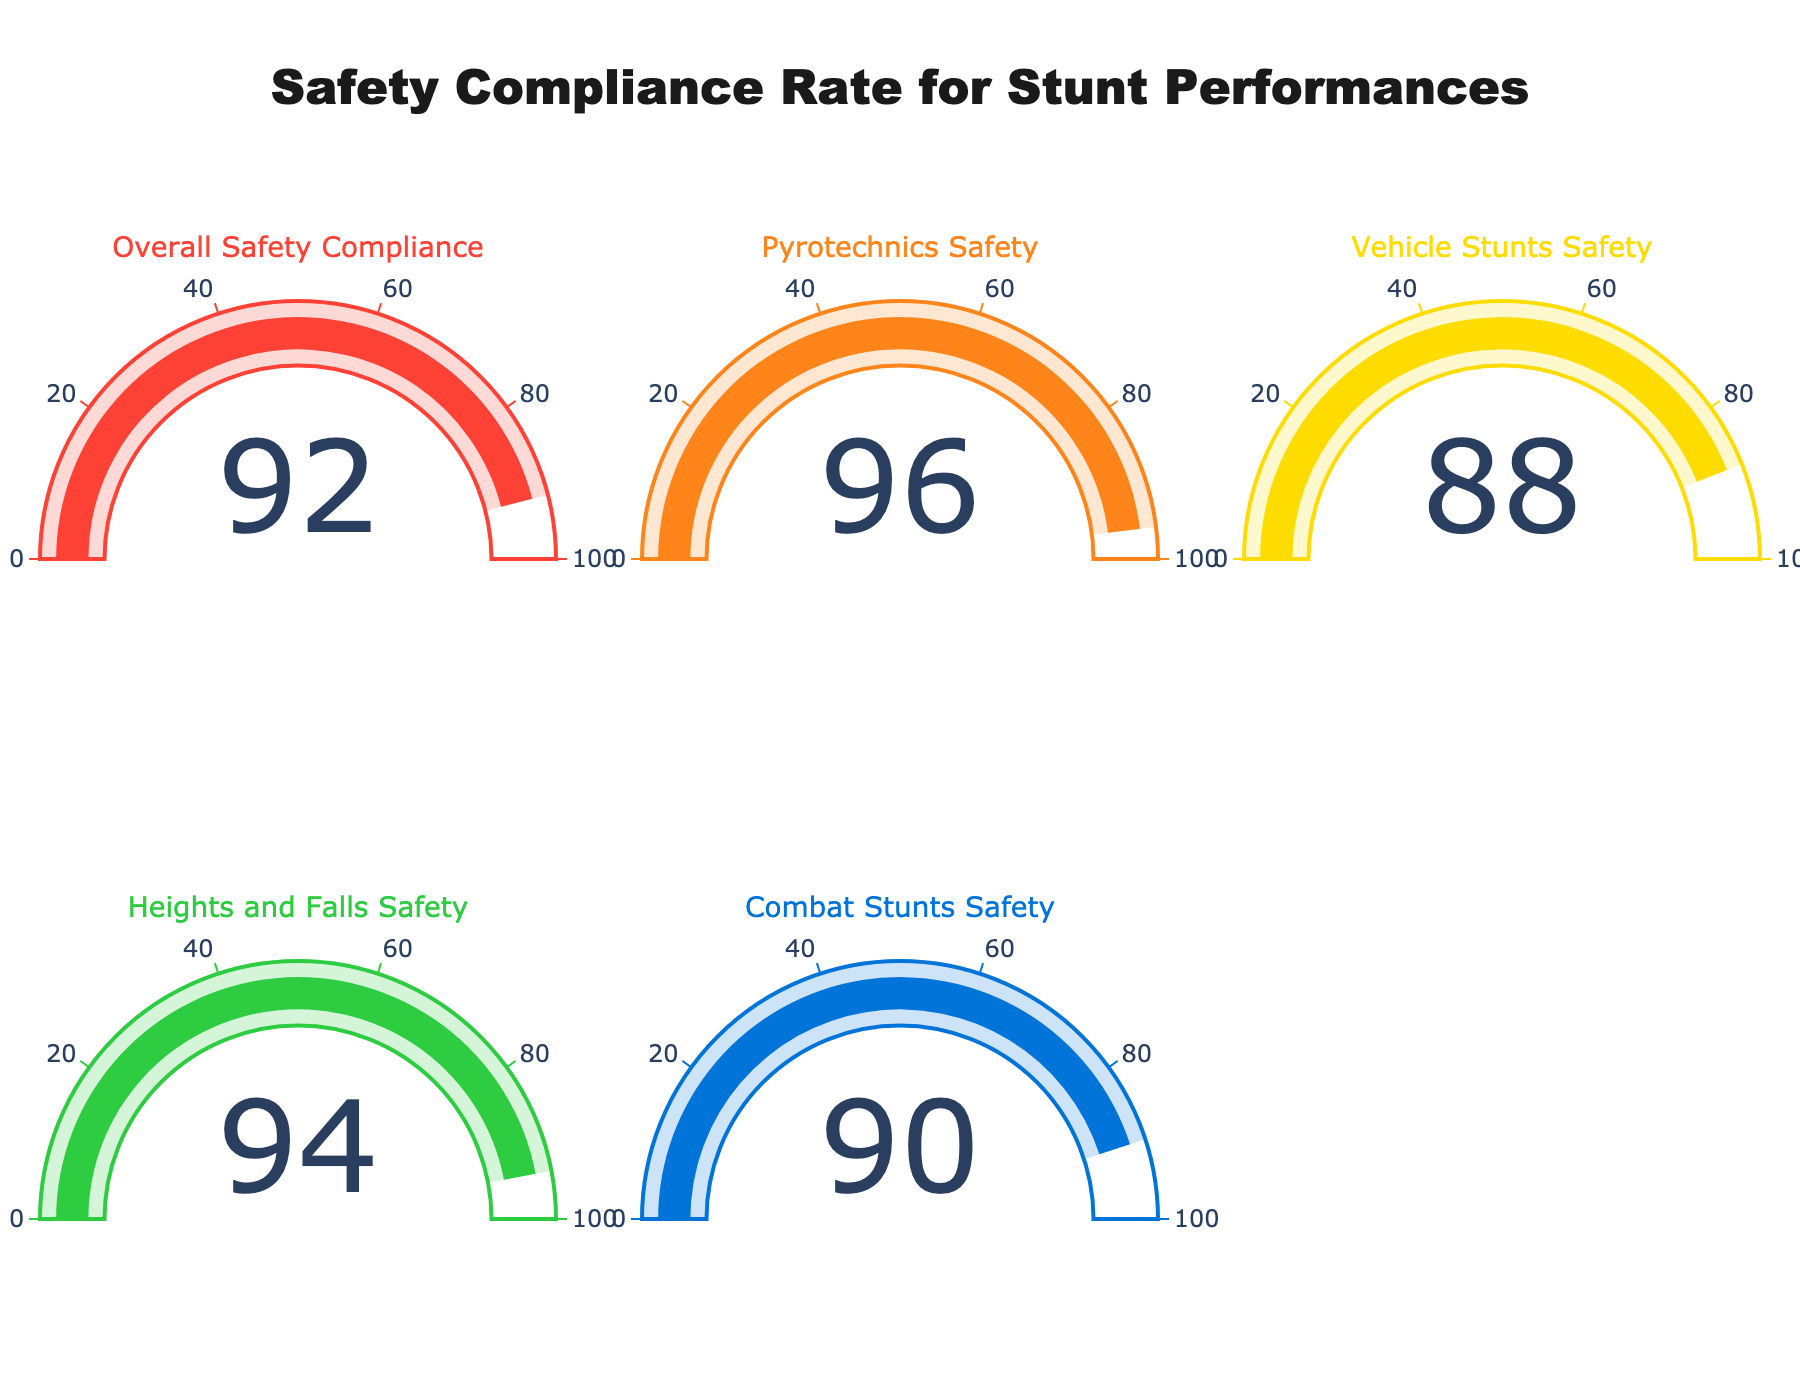what is the safety compliance rate for pyrotechnics compared to vehicle stunts? The compliance rate for Pyrotechnics Safety is 96, while for Vehicle Stunts Safety is 88. 96 is greater than 88, meaning Pyrotechnics Safety has a higher compliance rate.
Answer: Pyrotechnics Safety has a higher compliance rate What is the lowest safety compliance rate shown in the chart? By looking at all the gauges, the lowest compliance rate is 88, which is for Vehicle Stunts Safety.
Answer: 88 Which category has a compliance rate of 92? The gauge chart with the value of 92 corresponds to the "Overall Safety Compliance" category.
Answer: Overall Safety Compliance How much higher is the compliance rate of Heights and Falls Safety compared to Combat Stunts Safety? Heights and Falls Safety has a compliance rate of 94 while Combat Stunts Safety has a compliance rate of 90. The difference between them is 94 - 90 = 4.
Answer: 4 What is the average compliance rate across all categories? The compliance rates are: 92, 96, 88, 94, and 90. Summing these gives 92 + 96 + 88 + 94 + 90 = 460. There are 5 categories, so the average is 460 / 5 = 92.
Answer: 92 Which two categories have the closest safety compliance rates? By comparing the values, the two categories with the closest compliance rates are Combat Stunts Safety (90) and Overall Safety Compliance (92). The difference between them is 2.
Answer: Combat Stunts Safety and Overall Safety Compliance How many categories have a compliance rate above 90? The categories with compliance rates above 90 are Overall Safety Compliance (92), Pyrotechnics Safety (96), and Heights and Falls Safety (94), which makes a total of 3 categories.
Answer: 3 Is there any category with a perfect safety compliance rate of 100? By examining the gauges, no category shows a compliance rate of 100.
Answer: No 